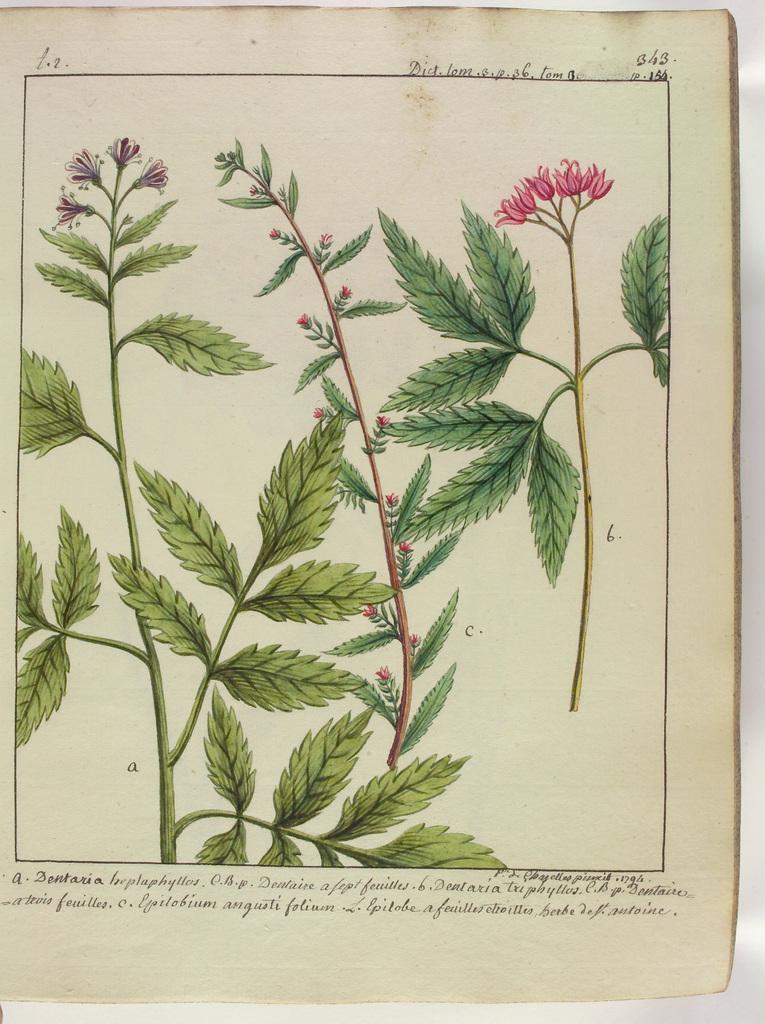Describe this image in one or two sentences. In this image I can see a paper and on it I can see the depiction picture of few plants and of few flowers. I can also see something is written on the top and on the bottom side of the paper. 